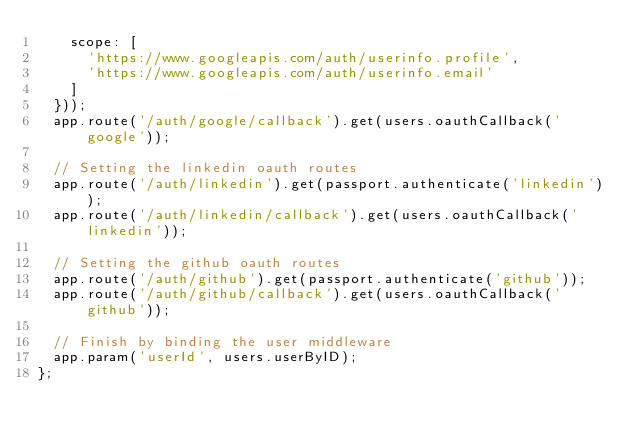Convert code to text. <code><loc_0><loc_0><loc_500><loc_500><_JavaScript_>		scope: [
			'https://www.googleapis.com/auth/userinfo.profile',
			'https://www.googleapis.com/auth/userinfo.email'
		]
	}));
	app.route('/auth/google/callback').get(users.oauthCallback('google'));

	// Setting the linkedin oauth routes
	app.route('/auth/linkedin').get(passport.authenticate('linkedin'));
	app.route('/auth/linkedin/callback').get(users.oauthCallback('linkedin'));
	
	// Setting the github oauth routes
	app.route('/auth/github').get(passport.authenticate('github'));
	app.route('/auth/github/callback').get(users.oauthCallback('github'));

	// Finish by binding the user middleware
	app.param('userId', users.userByID);
};
</code> 